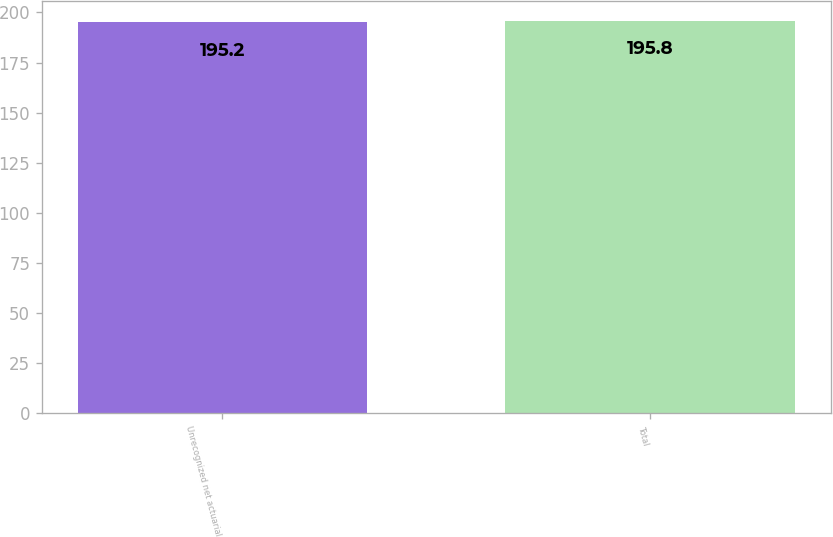<chart> <loc_0><loc_0><loc_500><loc_500><bar_chart><fcel>Unrecognized net actuarial<fcel>Total<nl><fcel>195.2<fcel>195.8<nl></chart> 